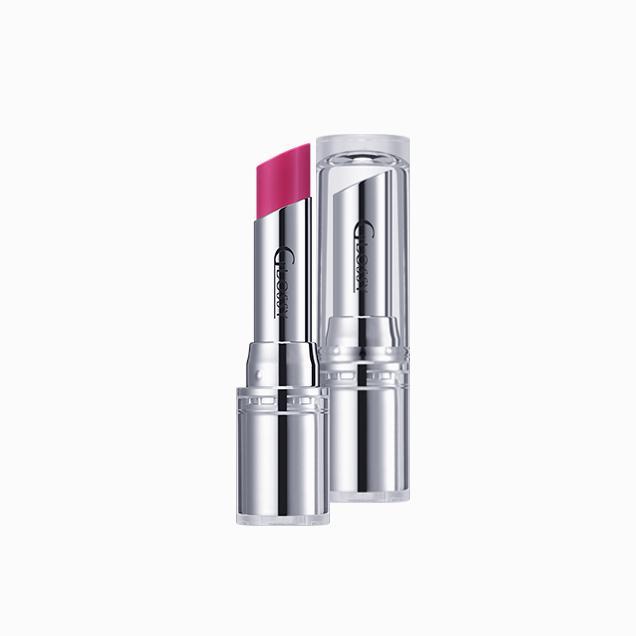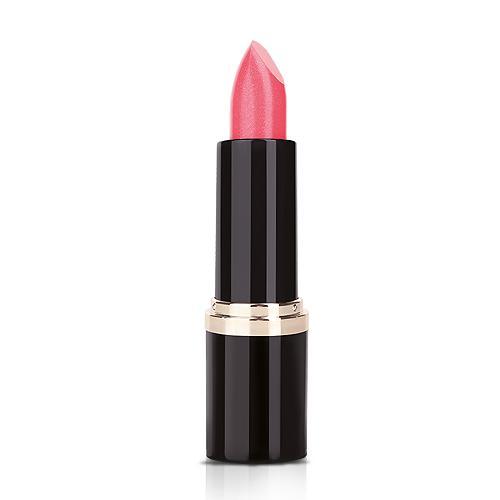The first image is the image on the left, the second image is the image on the right. For the images shown, is this caption "Each image shows just one lipstick next to its cap." true? Answer yes or no. No. The first image is the image on the left, the second image is the image on the right. Evaluate the accuracy of this statement regarding the images: "The lipstick in the right photo has a black case.". Is it true? Answer yes or no. Yes. 